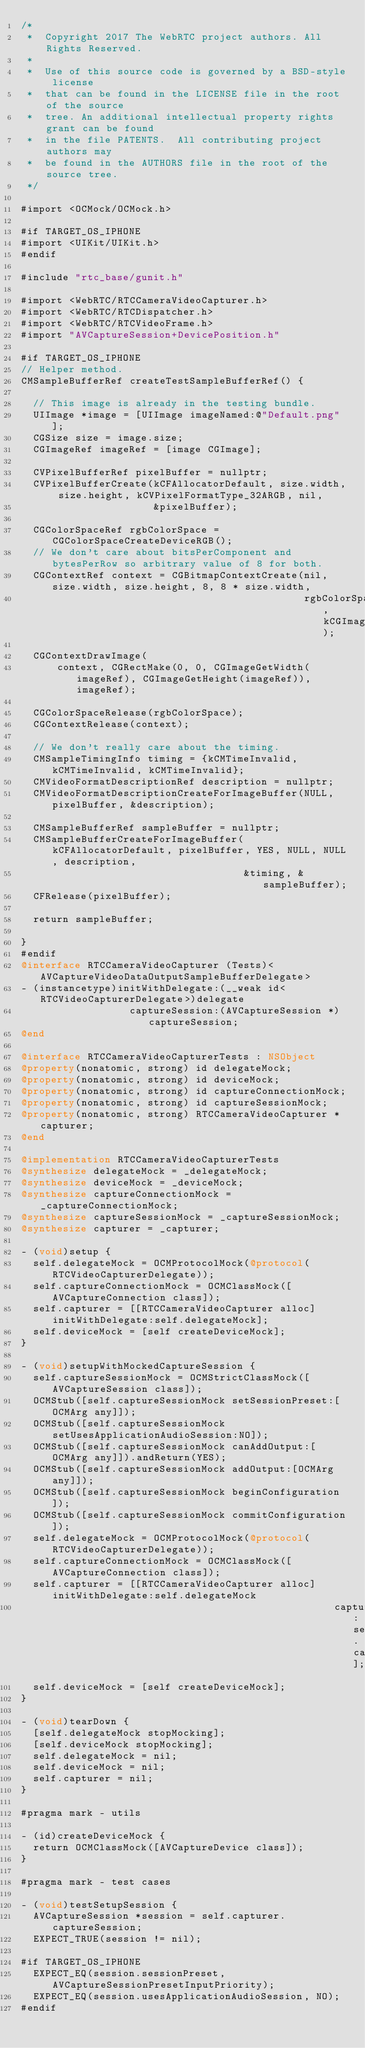Convert code to text. <code><loc_0><loc_0><loc_500><loc_500><_ObjectiveC_>/*
 *  Copyright 2017 The WebRTC project authors. All Rights Reserved.
 *
 *  Use of this source code is governed by a BSD-style license
 *  that can be found in the LICENSE file in the root of the source
 *  tree. An additional intellectual property rights grant can be found
 *  in the file PATENTS.  All contributing project authors may
 *  be found in the AUTHORS file in the root of the source tree.
 */

#import <OCMock/OCMock.h>

#if TARGET_OS_IPHONE
#import <UIKit/UIKit.h>
#endif

#include "rtc_base/gunit.h"

#import <WebRTC/RTCCameraVideoCapturer.h>
#import <WebRTC/RTCDispatcher.h>
#import <WebRTC/RTCVideoFrame.h>
#import "AVCaptureSession+DevicePosition.h"

#if TARGET_OS_IPHONE
// Helper method.
CMSampleBufferRef createTestSampleBufferRef() {

  // This image is already in the testing bundle.
  UIImage *image = [UIImage imageNamed:@"Default.png"];
  CGSize size = image.size;
  CGImageRef imageRef = [image CGImage];

  CVPixelBufferRef pixelBuffer = nullptr;
  CVPixelBufferCreate(kCFAllocatorDefault, size.width, size.height, kCVPixelFormatType_32ARGB, nil,
                      &pixelBuffer);

  CGColorSpaceRef rgbColorSpace = CGColorSpaceCreateDeviceRGB();
  // We don't care about bitsPerComponent and bytesPerRow so arbitrary value of 8 for both.
  CGContextRef context = CGBitmapContextCreate(nil, size.width, size.height, 8, 8 * size.width,
                                               rgbColorSpace, kCGImageAlphaPremultipliedFirst);

  CGContextDrawImage(
      context, CGRectMake(0, 0, CGImageGetWidth(imageRef), CGImageGetHeight(imageRef)), imageRef);

  CGColorSpaceRelease(rgbColorSpace);
  CGContextRelease(context);

  // We don't really care about the timing.
  CMSampleTimingInfo timing = {kCMTimeInvalid, kCMTimeInvalid, kCMTimeInvalid};
  CMVideoFormatDescriptionRef description = nullptr;
  CMVideoFormatDescriptionCreateForImageBuffer(NULL, pixelBuffer, &description);

  CMSampleBufferRef sampleBuffer = nullptr;
  CMSampleBufferCreateForImageBuffer(kCFAllocatorDefault, pixelBuffer, YES, NULL, NULL, description,
                                     &timing, &sampleBuffer);
  CFRelease(pixelBuffer);

  return sampleBuffer;

}
#endif
@interface RTCCameraVideoCapturer (Tests)<AVCaptureVideoDataOutputSampleBufferDelegate>
- (instancetype)initWithDelegate:(__weak id<RTCVideoCapturerDelegate>)delegate
                  captureSession:(AVCaptureSession *)captureSession;
@end

@interface RTCCameraVideoCapturerTests : NSObject
@property(nonatomic, strong) id delegateMock;
@property(nonatomic, strong) id deviceMock;
@property(nonatomic, strong) id captureConnectionMock;
@property(nonatomic, strong) id captureSessionMock;
@property(nonatomic, strong) RTCCameraVideoCapturer *capturer;
@end

@implementation RTCCameraVideoCapturerTests
@synthesize delegateMock = _delegateMock;
@synthesize deviceMock = _deviceMock;
@synthesize captureConnectionMock = _captureConnectionMock;
@synthesize captureSessionMock = _captureSessionMock;
@synthesize capturer = _capturer;

- (void)setup {
  self.delegateMock = OCMProtocolMock(@protocol(RTCVideoCapturerDelegate));
  self.captureConnectionMock = OCMClassMock([AVCaptureConnection class]);
  self.capturer = [[RTCCameraVideoCapturer alloc] initWithDelegate:self.delegateMock];
  self.deviceMock = [self createDeviceMock];
}

- (void)setupWithMockedCaptureSession {
  self.captureSessionMock = OCMStrictClassMock([AVCaptureSession class]);
  OCMStub([self.captureSessionMock setSessionPreset:[OCMArg any]]);
  OCMStub([self.captureSessionMock setUsesApplicationAudioSession:NO]);
  OCMStub([self.captureSessionMock canAddOutput:[OCMArg any]]).andReturn(YES);
  OCMStub([self.captureSessionMock addOutput:[OCMArg any]]);
  OCMStub([self.captureSessionMock beginConfiguration]);
  OCMStub([self.captureSessionMock commitConfiguration]);
  self.delegateMock = OCMProtocolMock(@protocol(RTCVideoCapturerDelegate));
  self.captureConnectionMock = OCMClassMock([AVCaptureConnection class]);
  self.capturer = [[RTCCameraVideoCapturer alloc] initWithDelegate:self.delegateMock
                                                    captureSession:self.captureSessionMock];
  self.deviceMock = [self createDeviceMock];
}

- (void)tearDown {
  [self.delegateMock stopMocking];
  [self.deviceMock stopMocking];
  self.delegateMock = nil;
  self.deviceMock = nil;
  self.capturer = nil;
}

#pragma mark - utils

- (id)createDeviceMock {
  return OCMClassMock([AVCaptureDevice class]);
}

#pragma mark - test cases

- (void)testSetupSession {
  AVCaptureSession *session = self.capturer.captureSession;
  EXPECT_TRUE(session != nil);

#if TARGET_OS_IPHONE
  EXPECT_EQ(session.sessionPreset, AVCaptureSessionPresetInputPriority);
  EXPECT_EQ(session.usesApplicationAudioSession, NO);
#endif</code> 